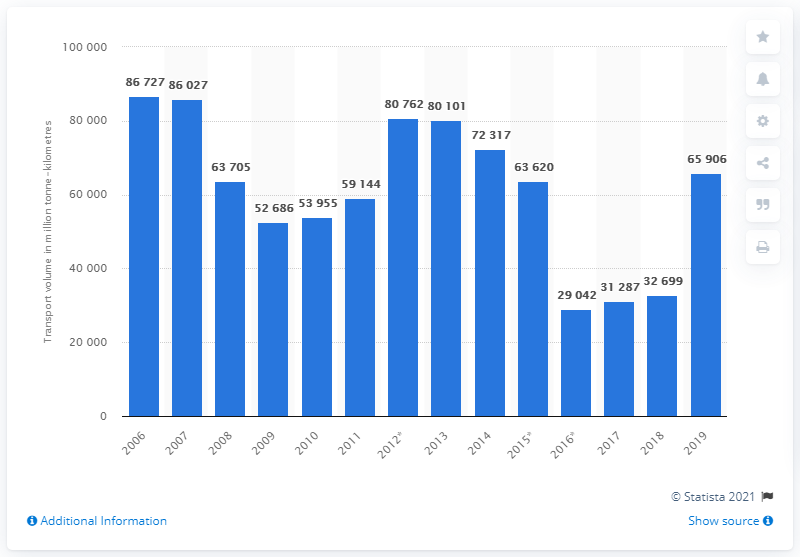Give some essential details in this illustration. The highest transport volume was achieved in the inland waterway freight sector in 2006. In 2019, the volume of inland waterway freight transport in Russia was approximately 65,906 metric tons. 